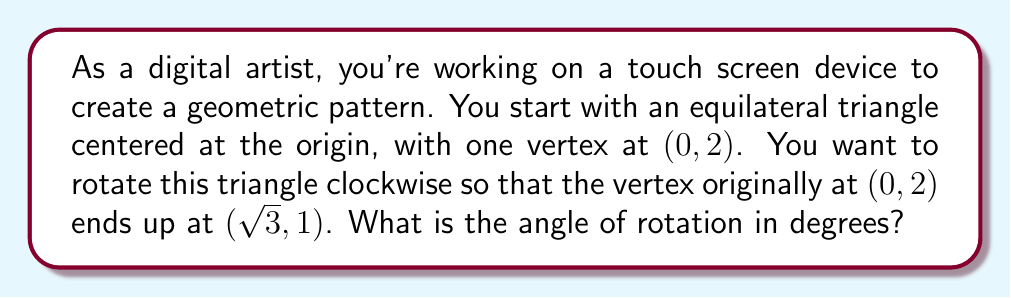Show me your answer to this math problem. Let's approach this step-by-step:

1) First, we need to understand what we're given:
   - We have an equilateral triangle centered at the origin.
   - One vertex starts at $(0, 2)$.
   - After rotation, this vertex ends up at $(\sqrt{3}, 1)$.

2) To find the angle of rotation, we can use the arctangent function. We'll calculate the initial and final angles from the positive x-axis, then find the difference.

3) For the initial position $(0, 2)$:
   - The angle from the x-axis is 90°, or $\frac{\pi}{2}$ radians.

4) For the final position $(\sqrt{3}, 1)$:
   - We can calculate this angle using $\arctan(\frac{y}{x})$
   - $\theta = \arctan(\frac{1}{\sqrt{3}})$

5) The angle of rotation is the difference between these angles:
   $$\text{Rotation angle} = 90° - \arctan(\frac{1}{\sqrt{3}})$$

6) We know that $\arctan(\frac{1}{\sqrt{3}}) = 30°$, because this is a standard angle in the unit circle.

7) Therefore, the rotation angle is:
   $$90° - 30° = 60°$$

This makes sense geometrically, as 60° is exactly one-third of a full 180° rotation, which would align with the symmetry of an equilateral triangle.
Answer: The angle of rotation is 60°. 